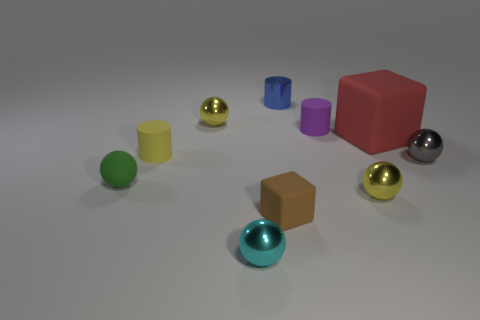Is there another thing that has the same material as the tiny brown thing?
Offer a terse response. Yes. Are there fewer tiny yellow spheres than shiny balls?
Your response must be concise. Yes. What is the cylinder in front of the cube behind the small yellow ball in front of the large red rubber cube made of?
Provide a succinct answer. Rubber. Is the number of tiny yellow things that are in front of the gray object less than the number of brown cubes?
Offer a terse response. No. Is the size of the metal object in front of the brown object the same as the big matte object?
Provide a succinct answer. No. How many yellow balls are both in front of the tiny green rubber ball and behind the green matte object?
Offer a very short reply. 0. There is a cube behind the tiny rubber sphere on the left side of the cyan ball; what is its size?
Provide a succinct answer. Large. Are there fewer tiny purple cylinders behind the metallic cylinder than tiny yellow things that are behind the tiny green rubber sphere?
Offer a terse response. Yes. Do the tiny sphere behind the gray object and the tiny cylinder in front of the red matte cube have the same color?
Ensure brevity in your answer.  Yes. There is a tiny sphere that is both on the right side of the small purple matte thing and in front of the small gray metal thing; what material is it?
Your response must be concise. Metal. 